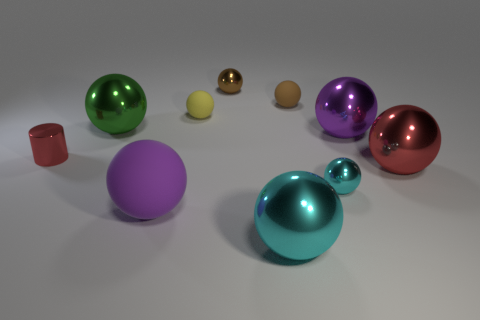Subtract 2 spheres. How many spheres are left? 7 Subtract all purple spheres. How many spheres are left? 7 Subtract all yellow matte spheres. How many spheres are left? 8 Subtract all brown spheres. Subtract all blue cylinders. How many spheres are left? 7 Subtract all balls. How many objects are left? 1 Subtract 1 brown spheres. How many objects are left? 9 Subtract all shiny cylinders. Subtract all tiny brown metallic balls. How many objects are left? 8 Add 1 shiny things. How many shiny things are left? 8 Add 1 brown rubber balls. How many brown rubber balls exist? 2 